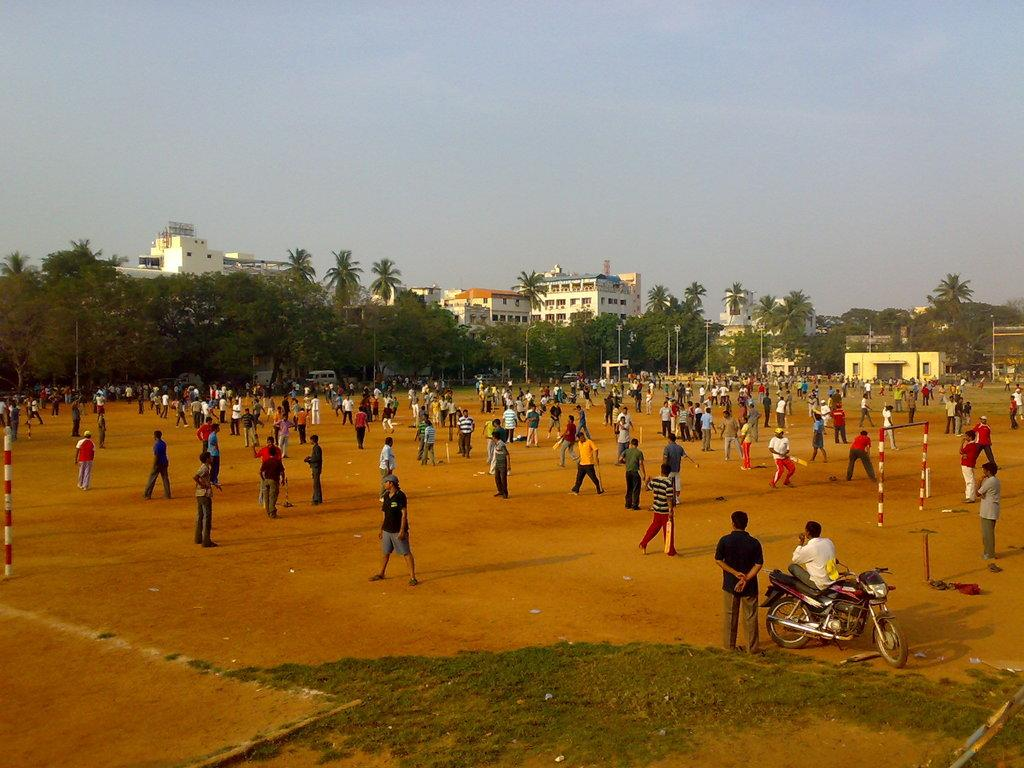What is the main setting of the image? The image depicts a ground. What is happening on the ground? There are many people on the ground. Can you describe the person on the right side of the image? There is a person sitting on a motorcycle on the right side. What can be seen in the background of the image? There are trees, buildings, and the sky visible in the background. What type of ray is flying over the nation in the image? There is no ray or nation present in the image; it depicts a ground with people and a person on a motorcycle. What type of approval is being given by the person on the motorcycle in the image? There is no indication of approval or any related action in the image; the person is simply sitting on a motorcycle. 